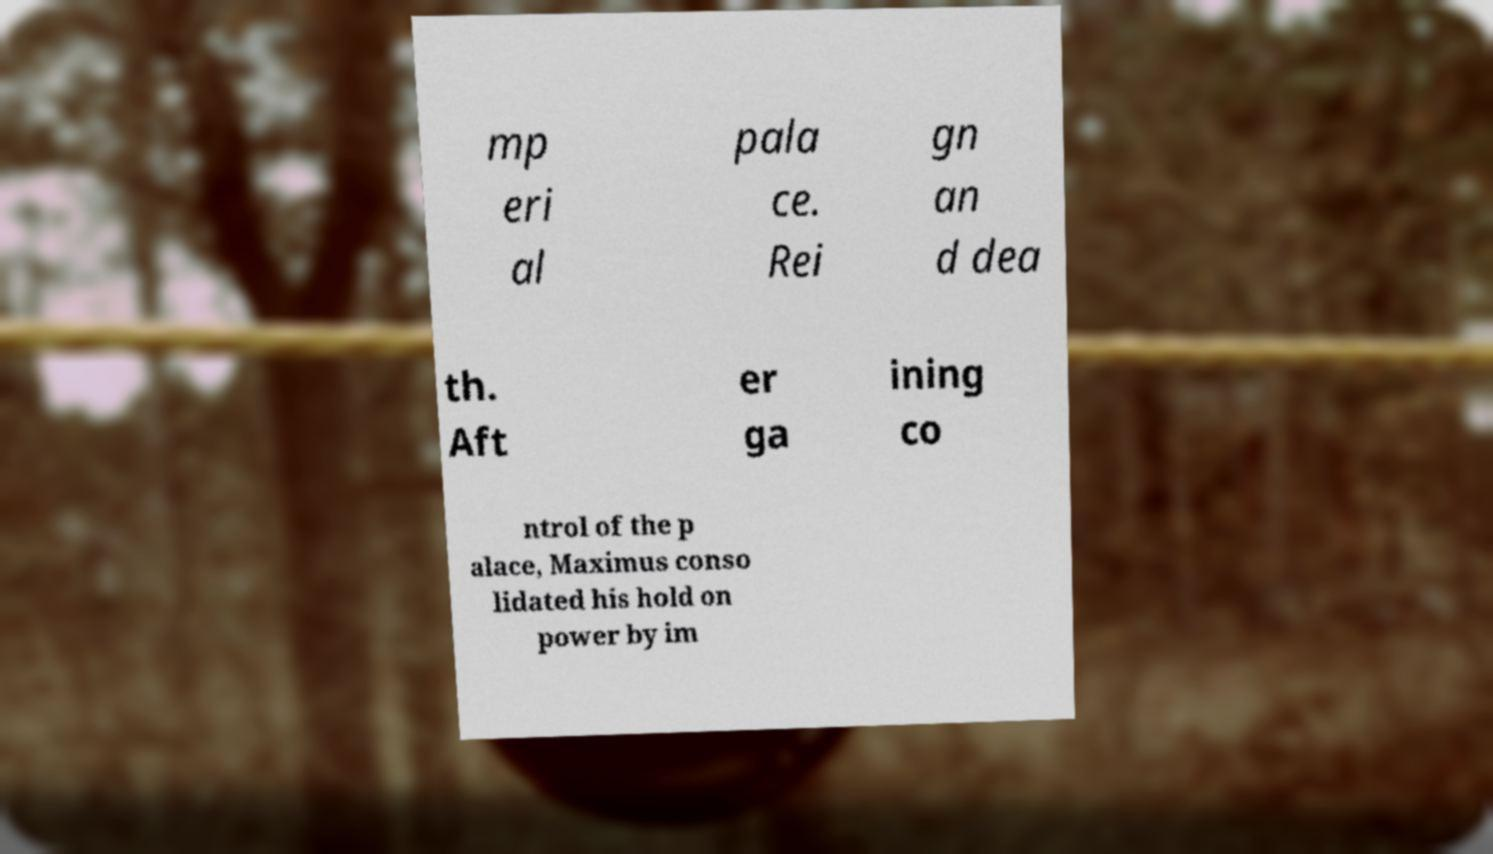Can you accurately transcribe the text from the provided image for me? mp eri al pala ce. Rei gn an d dea th. Aft er ga ining co ntrol of the p alace, Maximus conso lidated his hold on power by im 